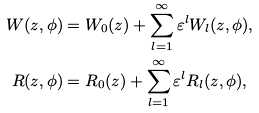Convert formula to latex. <formula><loc_0><loc_0><loc_500><loc_500>W ( z , \phi ) & = W _ { 0 } ( z ) + \sum _ { l = 1 } ^ { \infty } \varepsilon ^ { l } W _ { l } ( z , \phi ) , \\ R ( z , \phi ) & = R _ { 0 } ( z ) + \sum _ { l = 1 } ^ { \infty } \varepsilon ^ { l } R _ { l } ( z , \phi ) ,</formula> 